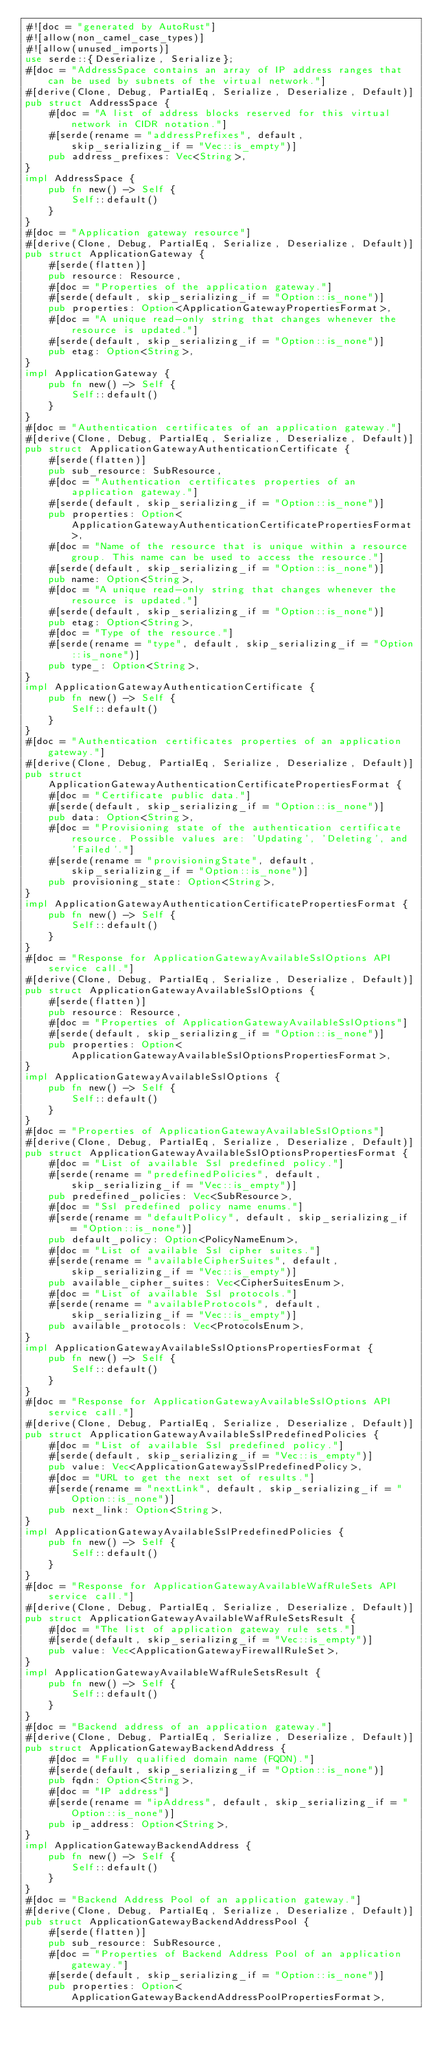Convert code to text. <code><loc_0><loc_0><loc_500><loc_500><_Rust_>#![doc = "generated by AutoRust"]
#![allow(non_camel_case_types)]
#![allow(unused_imports)]
use serde::{Deserialize, Serialize};
#[doc = "AddressSpace contains an array of IP address ranges that can be used by subnets of the virtual network."]
#[derive(Clone, Debug, PartialEq, Serialize, Deserialize, Default)]
pub struct AddressSpace {
    #[doc = "A list of address blocks reserved for this virtual network in CIDR notation."]
    #[serde(rename = "addressPrefixes", default, skip_serializing_if = "Vec::is_empty")]
    pub address_prefixes: Vec<String>,
}
impl AddressSpace {
    pub fn new() -> Self {
        Self::default()
    }
}
#[doc = "Application gateway resource"]
#[derive(Clone, Debug, PartialEq, Serialize, Deserialize, Default)]
pub struct ApplicationGateway {
    #[serde(flatten)]
    pub resource: Resource,
    #[doc = "Properties of the application gateway."]
    #[serde(default, skip_serializing_if = "Option::is_none")]
    pub properties: Option<ApplicationGatewayPropertiesFormat>,
    #[doc = "A unique read-only string that changes whenever the resource is updated."]
    #[serde(default, skip_serializing_if = "Option::is_none")]
    pub etag: Option<String>,
}
impl ApplicationGateway {
    pub fn new() -> Self {
        Self::default()
    }
}
#[doc = "Authentication certificates of an application gateway."]
#[derive(Clone, Debug, PartialEq, Serialize, Deserialize, Default)]
pub struct ApplicationGatewayAuthenticationCertificate {
    #[serde(flatten)]
    pub sub_resource: SubResource,
    #[doc = "Authentication certificates properties of an application gateway."]
    #[serde(default, skip_serializing_if = "Option::is_none")]
    pub properties: Option<ApplicationGatewayAuthenticationCertificatePropertiesFormat>,
    #[doc = "Name of the resource that is unique within a resource group. This name can be used to access the resource."]
    #[serde(default, skip_serializing_if = "Option::is_none")]
    pub name: Option<String>,
    #[doc = "A unique read-only string that changes whenever the resource is updated."]
    #[serde(default, skip_serializing_if = "Option::is_none")]
    pub etag: Option<String>,
    #[doc = "Type of the resource."]
    #[serde(rename = "type", default, skip_serializing_if = "Option::is_none")]
    pub type_: Option<String>,
}
impl ApplicationGatewayAuthenticationCertificate {
    pub fn new() -> Self {
        Self::default()
    }
}
#[doc = "Authentication certificates properties of an application gateway."]
#[derive(Clone, Debug, PartialEq, Serialize, Deserialize, Default)]
pub struct ApplicationGatewayAuthenticationCertificatePropertiesFormat {
    #[doc = "Certificate public data."]
    #[serde(default, skip_serializing_if = "Option::is_none")]
    pub data: Option<String>,
    #[doc = "Provisioning state of the authentication certificate resource. Possible values are: 'Updating', 'Deleting', and 'Failed'."]
    #[serde(rename = "provisioningState", default, skip_serializing_if = "Option::is_none")]
    pub provisioning_state: Option<String>,
}
impl ApplicationGatewayAuthenticationCertificatePropertiesFormat {
    pub fn new() -> Self {
        Self::default()
    }
}
#[doc = "Response for ApplicationGatewayAvailableSslOptions API service call."]
#[derive(Clone, Debug, PartialEq, Serialize, Deserialize, Default)]
pub struct ApplicationGatewayAvailableSslOptions {
    #[serde(flatten)]
    pub resource: Resource,
    #[doc = "Properties of ApplicationGatewayAvailableSslOptions"]
    #[serde(default, skip_serializing_if = "Option::is_none")]
    pub properties: Option<ApplicationGatewayAvailableSslOptionsPropertiesFormat>,
}
impl ApplicationGatewayAvailableSslOptions {
    pub fn new() -> Self {
        Self::default()
    }
}
#[doc = "Properties of ApplicationGatewayAvailableSslOptions"]
#[derive(Clone, Debug, PartialEq, Serialize, Deserialize, Default)]
pub struct ApplicationGatewayAvailableSslOptionsPropertiesFormat {
    #[doc = "List of available Ssl predefined policy."]
    #[serde(rename = "predefinedPolicies", default, skip_serializing_if = "Vec::is_empty")]
    pub predefined_policies: Vec<SubResource>,
    #[doc = "Ssl predefined policy name enums."]
    #[serde(rename = "defaultPolicy", default, skip_serializing_if = "Option::is_none")]
    pub default_policy: Option<PolicyNameEnum>,
    #[doc = "List of available Ssl cipher suites."]
    #[serde(rename = "availableCipherSuites", default, skip_serializing_if = "Vec::is_empty")]
    pub available_cipher_suites: Vec<CipherSuitesEnum>,
    #[doc = "List of available Ssl protocols."]
    #[serde(rename = "availableProtocols", default, skip_serializing_if = "Vec::is_empty")]
    pub available_protocols: Vec<ProtocolsEnum>,
}
impl ApplicationGatewayAvailableSslOptionsPropertiesFormat {
    pub fn new() -> Self {
        Self::default()
    }
}
#[doc = "Response for ApplicationGatewayAvailableSslOptions API service call."]
#[derive(Clone, Debug, PartialEq, Serialize, Deserialize, Default)]
pub struct ApplicationGatewayAvailableSslPredefinedPolicies {
    #[doc = "List of available Ssl predefined policy."]
    #[serde(default, skip_serializing_if = "Vec::is_empty")]
    pub value: Vec<ApplicationGatewaySslPredefinedPolicy>,
    #[doc = "URL to get the next set of results."]
    #[serde(rename = "nextLink", default, skip_serializing_if = "Option::is_none")]
    pub next_link: Option<String>,
}
impl ApplicationGatewayAvailableSslPredefinedPolicies {
    pub fn new() -> Self {
        Self::default()
    }
}
#[doc = "Response for ApplicationGatewayAvailableWafRuleSets API service call."]
#[derive(Clone, Debug, PartialEq, Serialize, Deserialize, Default)]
pub struct ApplicationGatewayAvailableWafRuleSetsResult {
    #[doc = "The list of application gateway rule sets."]
    #[serde(default, skip_serializing_if = "Vec::is_empty")]
    pub value: Vec<ApplicationGatewayFirewallRuleSet>,
}
impl ApplicationGatewayAvailableWafRuleSetsResult {
    pub fn new() -> Self {
        Self::default()
    }
}
#[doc = "Backend address of an application gateway."]
#[derive(Clone, Debug, PartialEq, Serialize, Deserialize, Default)]
pub struct ApplicationGatewayBackendAddress {
    #[doc = "Fully qualified domain name (FQDN)."]
    #[serde(default, skip_serializing_if = "Option::is_none")]
    pub fqdn: Option<String>,
    #[doc = "IP address"]
    #[serde(rename = "ipAddress", default, skip_serializing_if = "Option::is_none")]
    pub ip_address: Option<String>,
}
impl ApplicationGatewayBackendAddress {
    pub fn new() -> Self {
        Self::default()
    }
}
#[doc = "Backend Address Pool of an application gateway."]
#[derive(Clone, Debug, PartialEq, Serialize, Deserialize, Default)]
pub struct ApplicationGatewayBackendAddressPool {
    #[serde(flatten)]
    pub sub_resource: SubResource,
    #[doc = "Properties of Backend Address Pool of an application gateway."]
    #[serde(default, skip_serializing_if = "Option::is_none")]
    pub properties: Option<ApplicationGatewayBackendAddressPoolPropertiesFormat>,</code> 